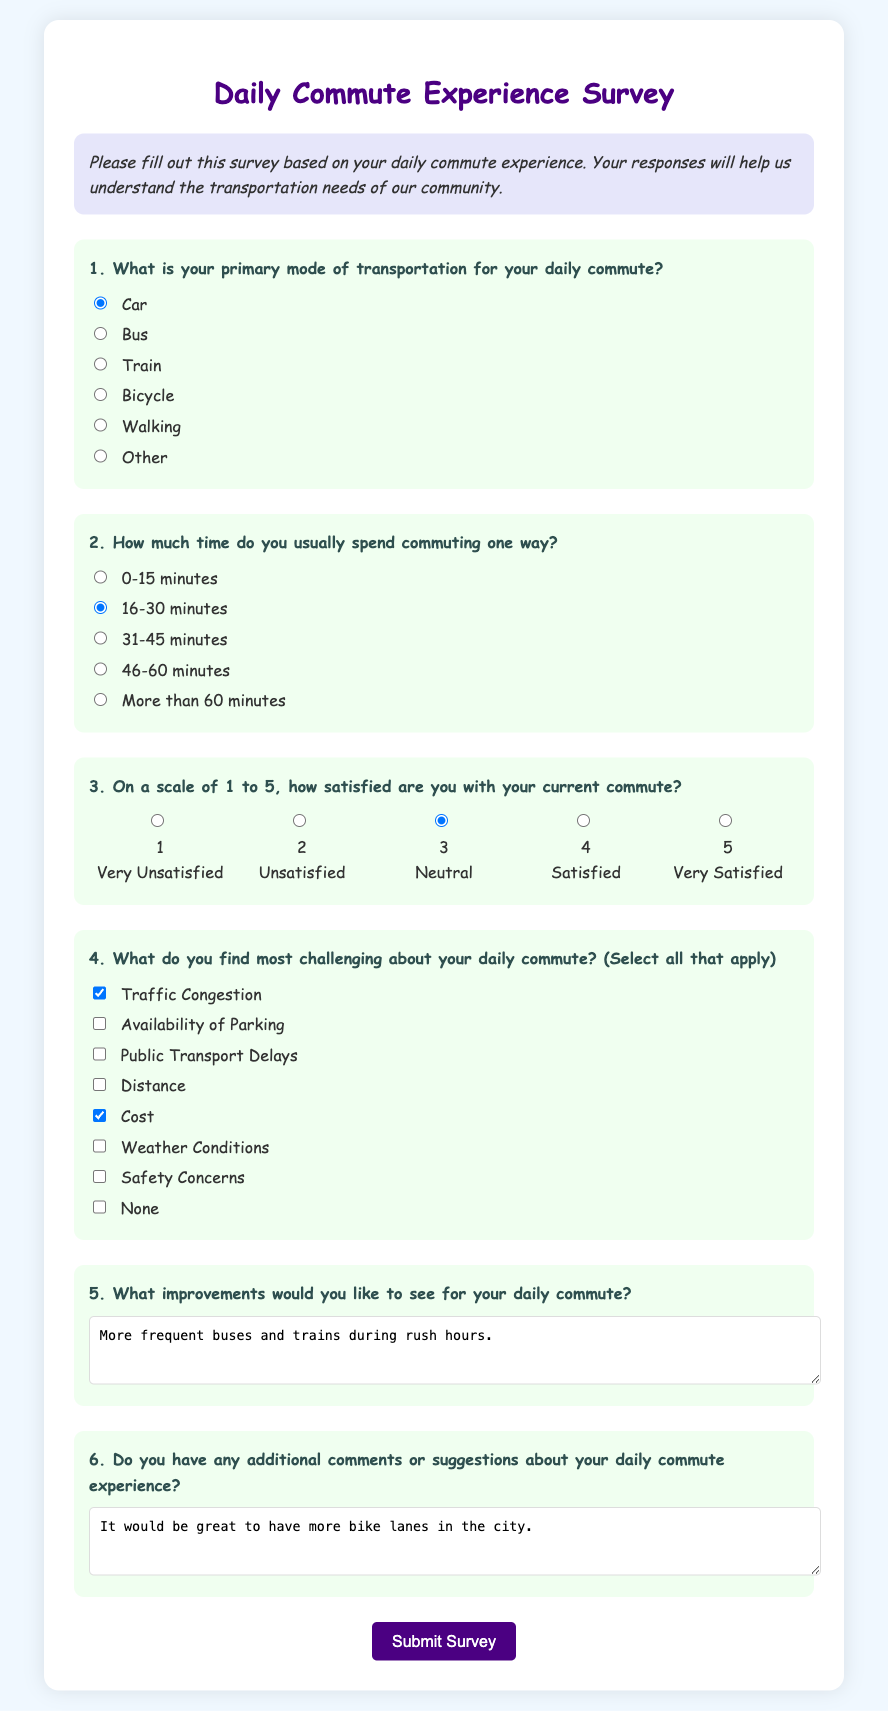What is the primary mode of transportation selected? The primary mode of transportation is indicated by the selected radio button in the survey, which is "Car."
Answer: Car How much time is usually spent commuting one way? The usual time spent commuting one way is indicated by the selected radio button in the survey, which is "16-30 minutes."
Answer: 16-30 minutes What is the satisfaction rating given by the respondent? The satisfaction rating is represented by the selected radio button in the survey, which is "3" for Neutral.
Answer: 3 What challenges are checked by the respondent? The challenges checked reflect the selected items in the survey; they are "Traffic Congestion" and "Cost."
Answer: Traffic Congestion, Cost What improvements does the respondent suggest for their daily commute? The suggested improvements are the contents of the textarea in the survey, which states "More frequent buses and trains during rush hours."
Answer: More frequent buses and trains during rush hours What additional comments does the respondent have about their commute? The additional comments are found in the corresponding textarea, stating "It would be great to have more bike lanes in the city."
Answer: It would be great to have more bike lanes in the city How many options are available for the primary mode of transportation? The number of options for the primary mode of transportation corresponds to the radio buttons listed in the survey, totaling six options.
Answer: 6 What scale is used to rate satisfaction in the survey? The satisfaction rating is measured on a scale of 1 to 5, as indicated in the question about satisfaction.
Answer: 1 to 5 How is the survey presented visually? The survey is structured with distinct sections, colors, and styles to enhance readability and engagement as per the HTML document's design.
Answer: Visually engaging design 